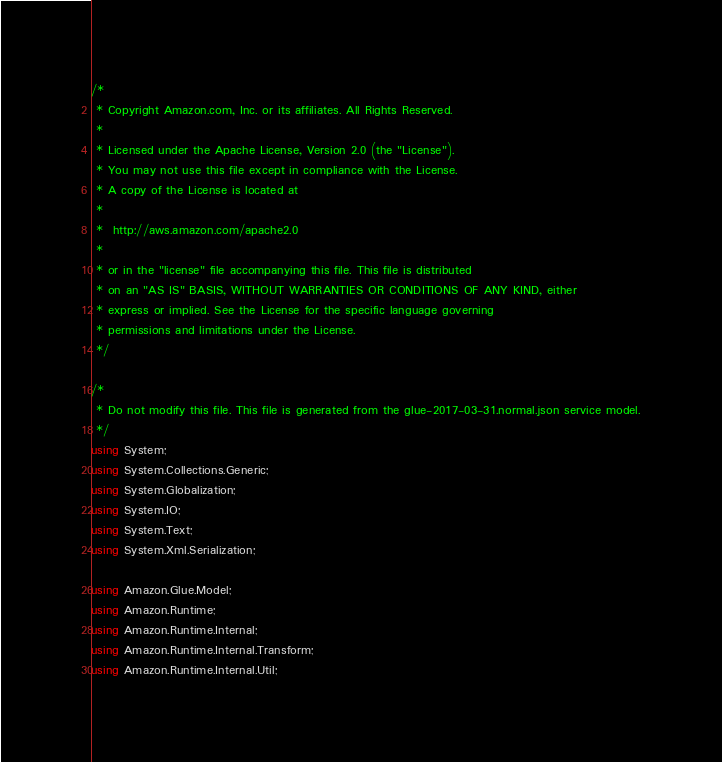<code> <loc_0><loc_0><loc_500><loc_500><_C#_>/*
 * Copyright Amazon.com, Inc. or its affiliates. All Rights Reserved.
 * 
 * Licensed under the Apache License, Version 2.0 (the "License").
 * You may not use this file except in compliance with the License.
 * A copy of the License is located at
 * 
 *  http://aws.amazon.com/apache2.0
 * 
 * or in the "license" file accompanying this file. This file is distributed
 * on an "AS IS" BASIS, WITHOUT WARRANTIES OR CONDITIONS OF ANY KIND, either
 * express or implied. See the License for the specific language governing
 * permissions and limitations under the License.
 */

/*
 * Do not modify this file. This file is generated from the glue-2017-03-31.normal.json service model.
 */
using System;
using System.Collections.Generic;
using System.Globalization;
using System.IO;
using System.Text;
using System.Xml.Serialization;

using Amazon.Glue.Model;
using Amazon.Runtime;
using Amazon.Runtime.Internal;
using Amazon.Runtime.Internal.Transform;
using Amazon.Runtime.Internal.Util;</code> 